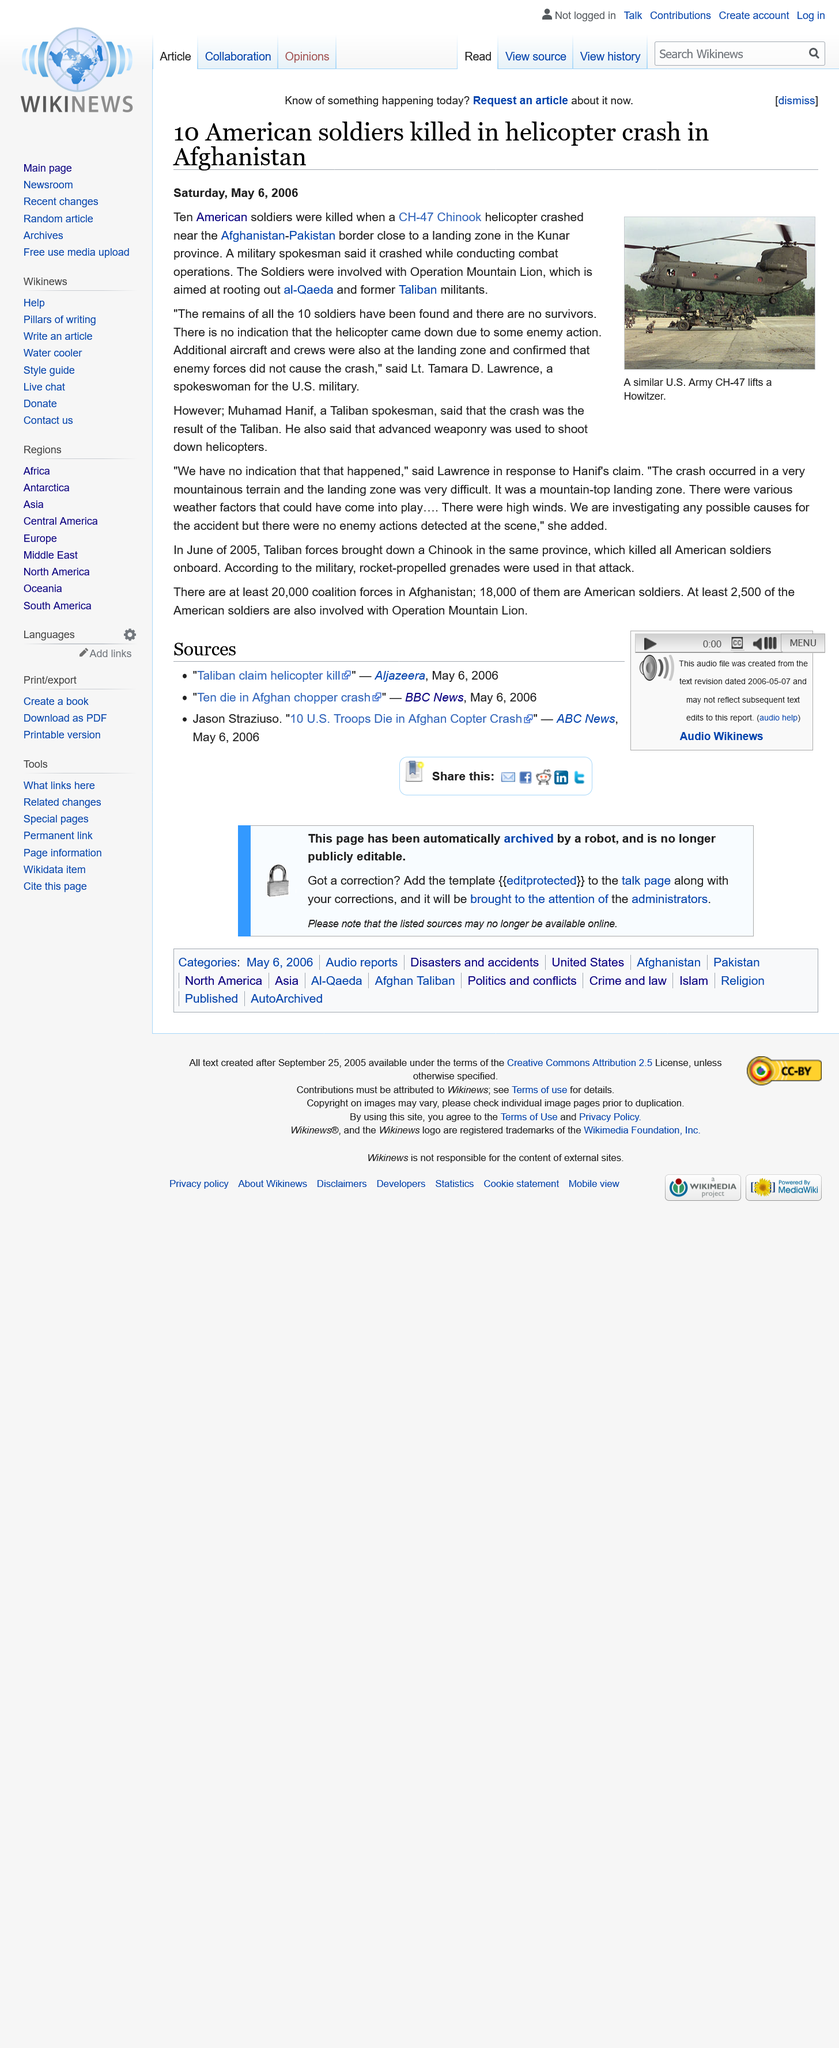Outline some significant characteristics in this image. The helicopter crash resulted in the loss of 10 American soldiers. This article was written on Saturday, May 6, 2006. A CH-47 Chinook helicopter crashed near the Afghanistan-Pakistan border, resulting in the deaths of American soldiers. 